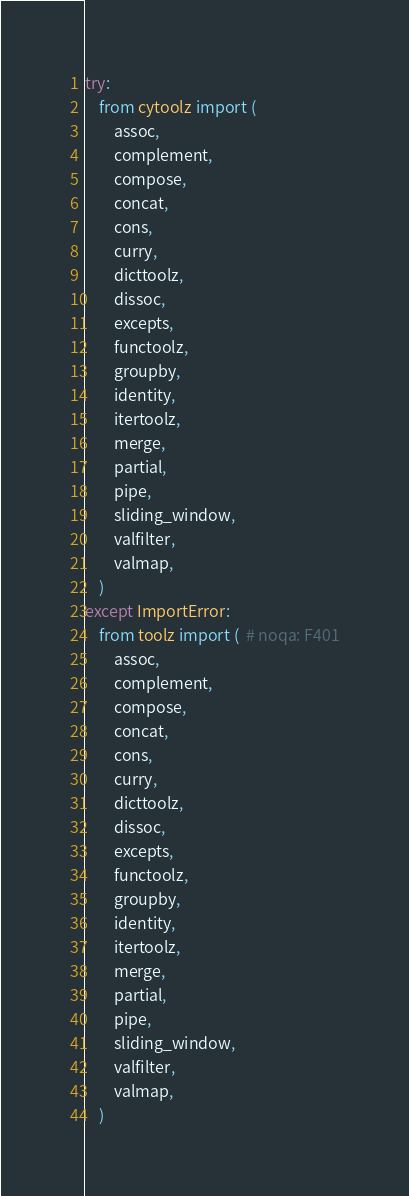Convert code to text. <code><loc_0><loc_0><loc_500><loc_500><_Python_>try:
    from cytoolz import (
        assoc,
        complement,
        compose,
        concat,
        cons,
        curry,
        dicttoolz,
        dissoc,
        excepts,
        functoolz,
        groupby,
        identity,
        itertoolz,
        merge,
        partial,
        pipe,
        sliding_window,
        valfilter,
        valmap,
    )
except ImportError:
    from toolz import (  # noqa: F401
        assoc,
        complement,
        compose,
        concat,
        cons,
        curry,
        dicttoolz,
        dissoc,
        excepts,
        functoolz,
        groupby,
        identity,
        itertoolz,
        merge,
        partial,
        pipe,
        sliding_window,
        valfilter,
        valmap,
    )
</code> 